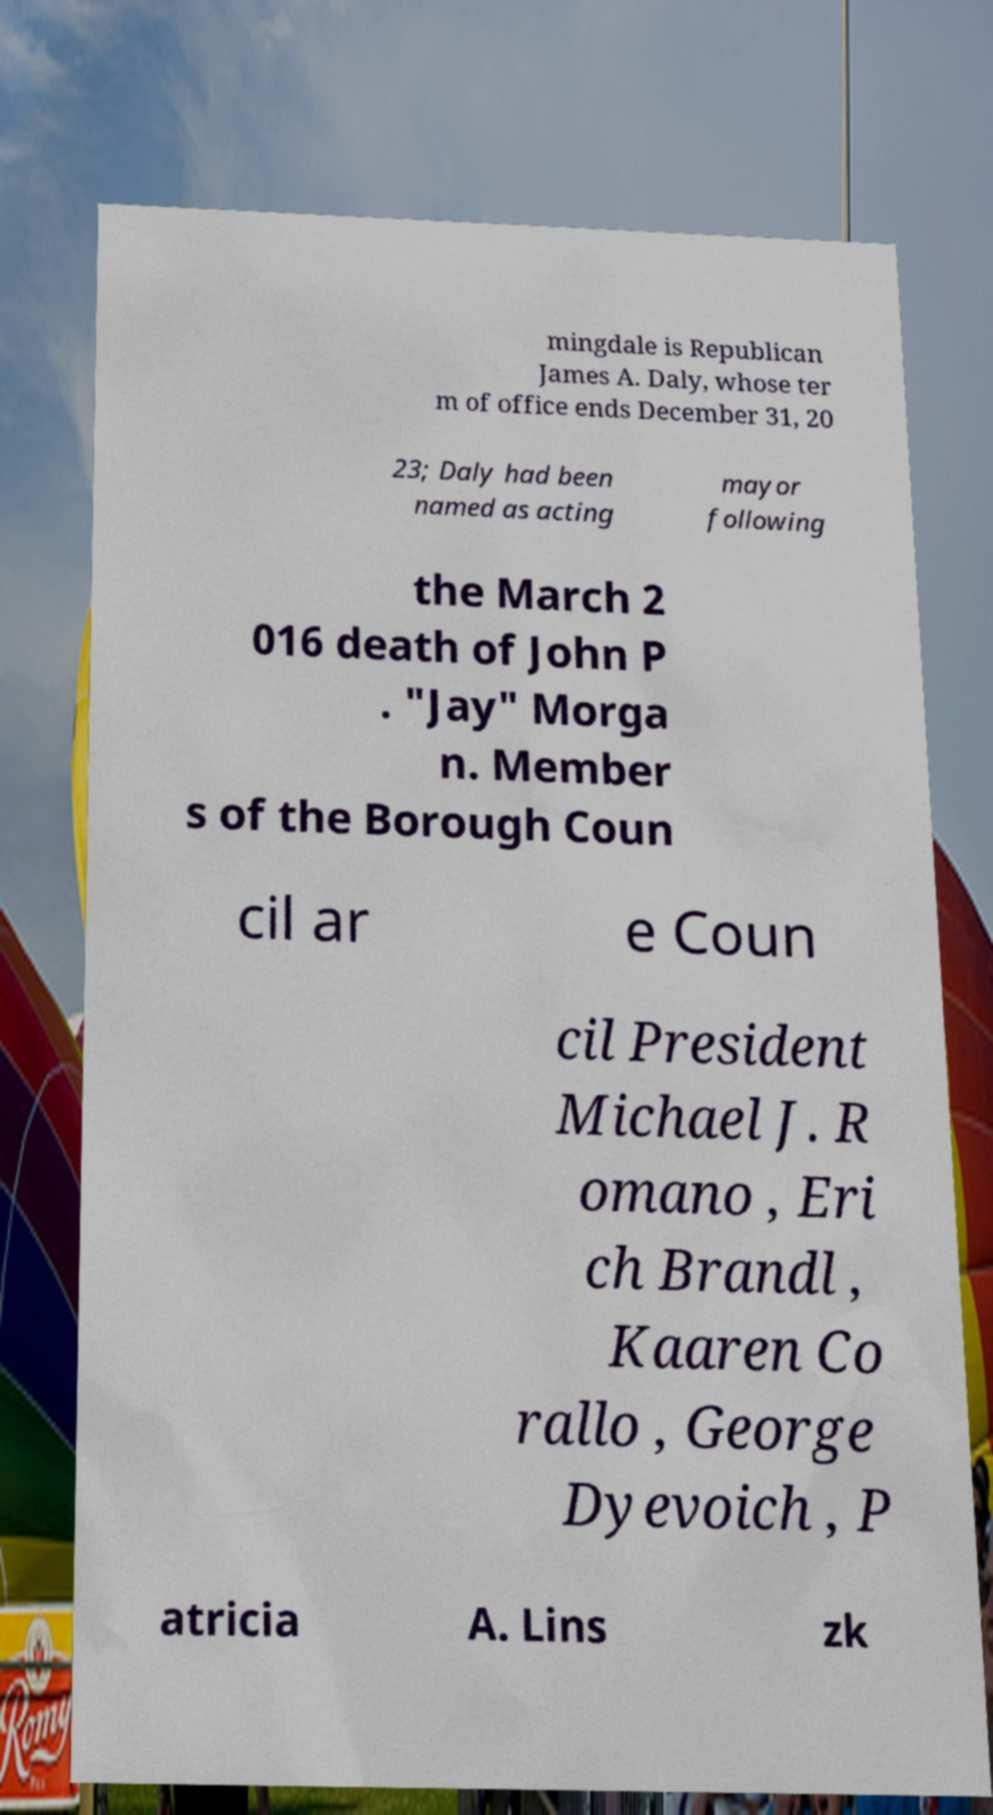There's text embedded in this image that I need extracted. Can you transcribe it verbatim? mingdale is Republican James A. Daly, whose ter m of office ends December 31, 20 23; Daly had been named as acting mayor following the March 2 016 death of John P . "Jay" Morga n. Member s of the Borough Coun cil ar e Coun cil President Michael J. R omano , Eri ch Brandl , Kaaren Co rallo , George Dyevoich , P atricia A. Lins zk 